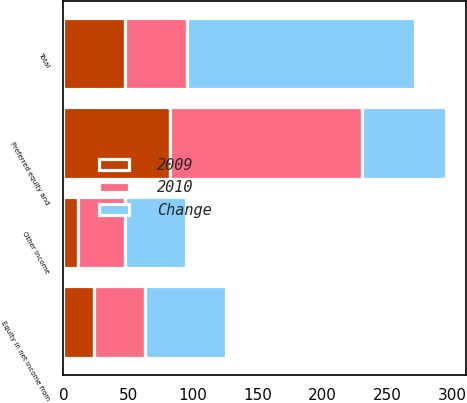<chart> <loc_0><loc_0><loc_500><loc_500><stacked_bar_chart><ecel><fcel>Equity in net income from<fcel>Preferred equity and<fcel>Other income<fcel>Total<nl><fcel>2010<fcel>39.6<fcel>147.9<fcel>36.2<fcel>47.8<nl><fcel>Change<fcel>62.9<fcel>65.6<fcel>47.4<fcel>175.9<nl><fcel>2009<fcel>23.3<fcel>82.3<fcel>11.2<fcel>47.8<nl></chart> 